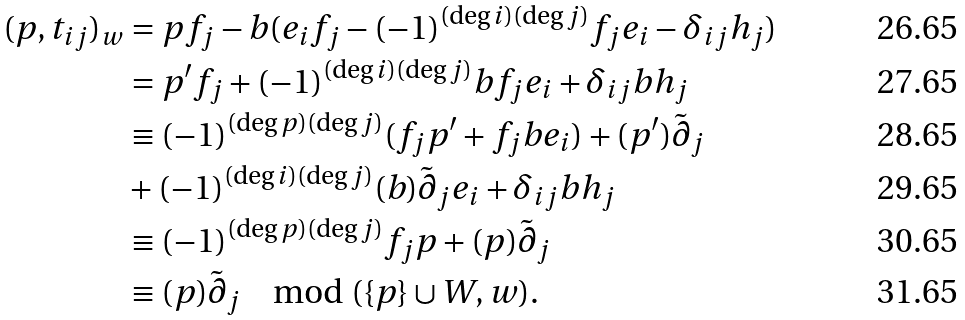Convert formula to latex. <formula><loc_0><loc_0><loc_500><loc_500>( p , t _ { i j } ) _ { w } & = p f _ { j } - b ( e _ { i } f _ { j } - ( - 1 ) ^ { ( \deg i ) ( \deg j ) } f _ { j } e _ { i } - \delta _ { i j } h _ { j } ) \\ & = p ^ { \prime } f _ { j } + ( - 1 ) ^ { ( \deg i ) ( \deg j ) } b f _ { j } e _ { i } + \delta _ { i j } b h _ { j } \\ & \equiv ( - 1 ) ^ { ( \deg p ) ( \deg j ) } ( f _ { j } p ^ { \prime } + f _ { j } b e _ { i } ) + ( p ^ { \prime } ) \tilde { \partial } _ { j } \\ & + ( - 1 ) ^ { ( \deg i ) ( \deg j ) } ( b ) \tilde { \partial } _ { j } e _ { i } + \delta _ { i j } b h _ { j } \\ & \equiv ( - 1 ) ^ { ( \deg p ) ( \deg j ) } f _ { j } p + ( p ) \tilde { \partial } _ { j } \\ & \equiv ( p ) \tilde { \partial } _ { j } \mod ( \{ p \} \cup W , w ) .</formula> 